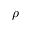<formula> <loc_0><loc_0><loc_500><loc_500>\rho</formula> 